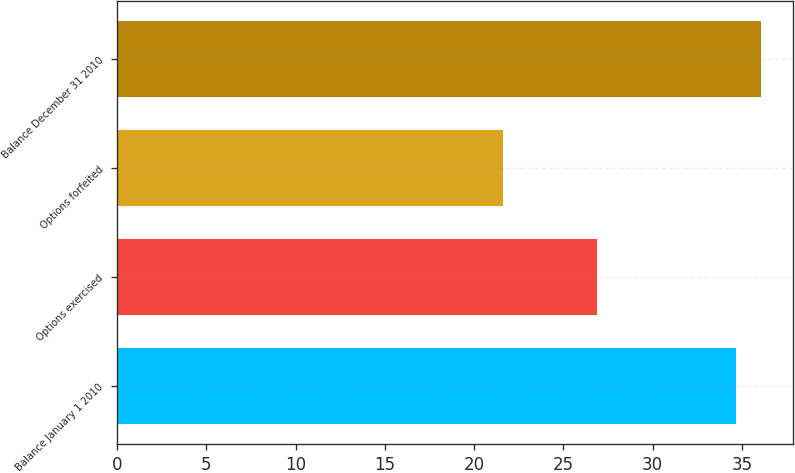<chart> <loc_0><loc_0><loc_500><loc_500><bar_chart><fcel>Balance January 1 2010<fcel>Options exercised<fcel>Options forfeited<fcel>Balance December 31 2010<nl><fcel>34.69<fcel>26.86<fcel>21.61<fcel>36.05<nl></chart> 